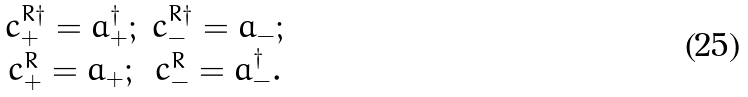<formula> <loc_0><loc_0><loc_500><loc_500>\begin{array} { c c } c _ { + } ^ { R \dagger } = a _ { + } ^ { \dagger } ; & c _ { - } ^ { R \dagger } = a _ { - } ; \\ c ^ { R } _ { + } = a _ { + } ; & c ^ { R } _ { - } = a _ { - } ^ { \dagger } . \end{array}</formula> 